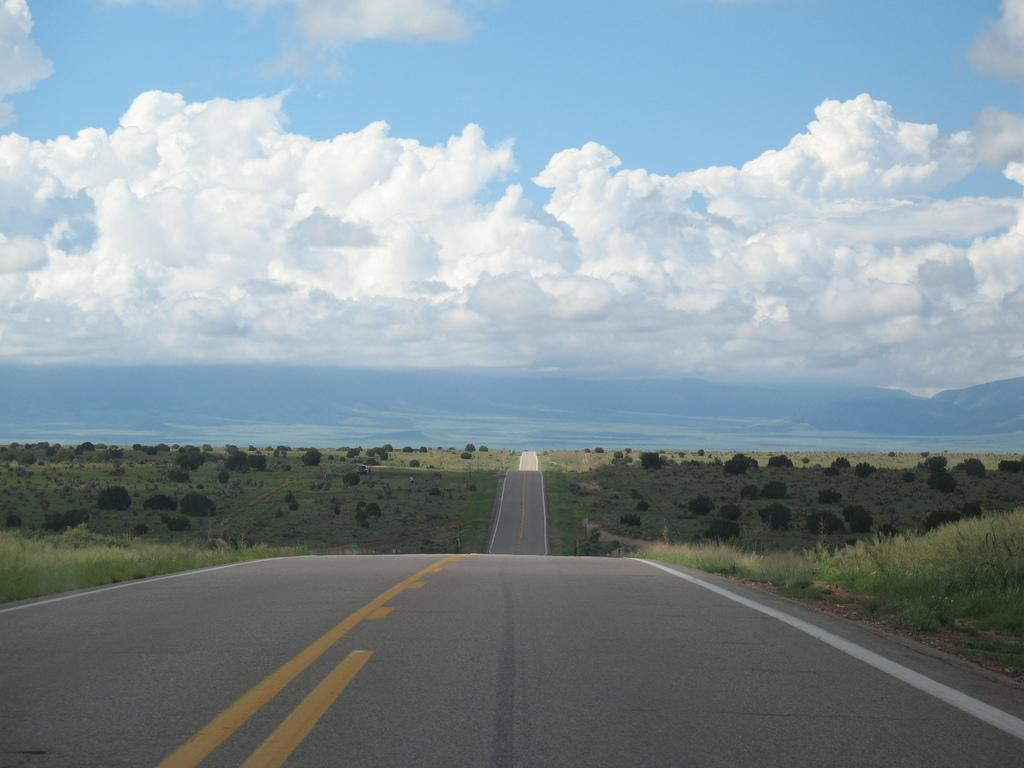What is the main feature in the center of the image? There is a road in the center of the image. What type of vegetation can be seen on the left side of the image? Trees and grass are present on the left side of the image. What type of vegetation can be seen on the right side of the image? Trees and grass are present on the right side of the image. What is visible in the sky at the top of the image? Clouds are visible in the sky at the top of the image. Where is the cannon located in the image? There is no cannon present in the image. How many people are in the group on the right side of the image? There is no group of people present in the image. 